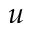<formula> <loc_0><loc_0><loc_500><loc_500>u</formula> 